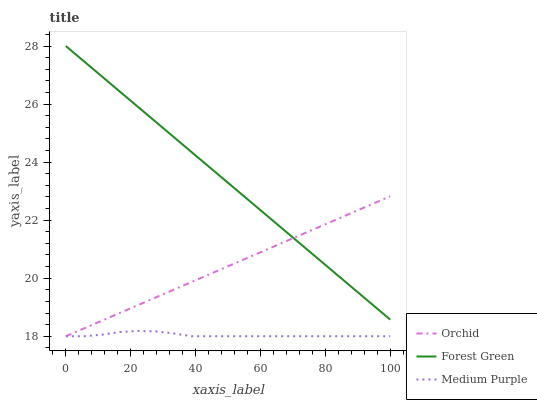Does Orchid have the minimum area under the curve?
Answer yes or no. No. Does Orchid have the maximum area under the curve?
Answer yes or no. No. Is Orchid the smoothest?
Answer yes or no. No. Is Orchid the roughest?
Answer yes or no. No. Does Forest Green have the lowest value?
Answer yes or no. No. Does Orchid have the highest value?
Answer yes or no. No. Is Medium Purple less than Forest Green?
Answer yes or no. Yes. Is Forest Green greater than Medium Purple?
Answer yes or no. Yes. Does Medium Purple intersect Forest Green?
Answer yes or no. No. 